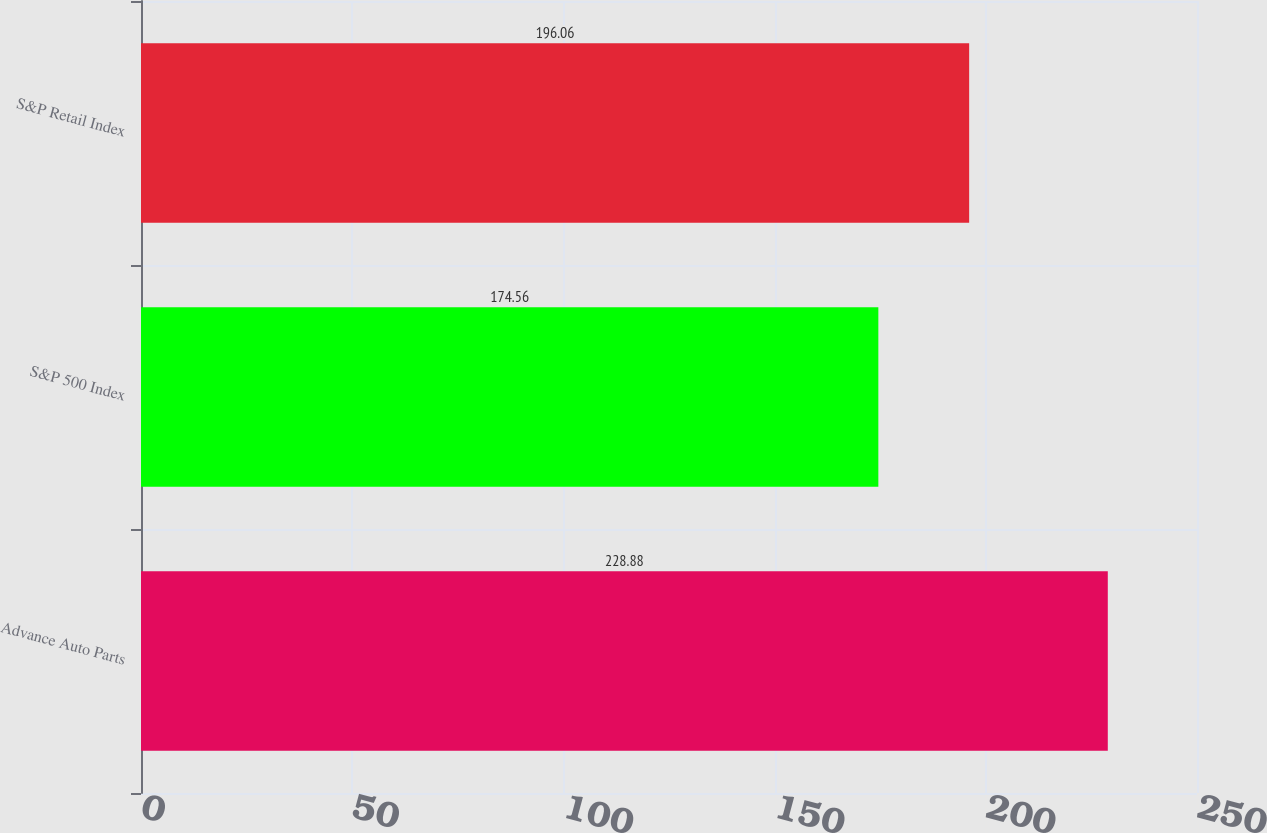<chart> <loc_0><loc_0><loc_500><loc_500><bar_chart><fcel>Advance Auto Parts<fcel>S&P 500 Index<fcel>S&P Retail Index<nl><fcel>228.88<fcel>174.56<fcel>196.06<nl></chart> 